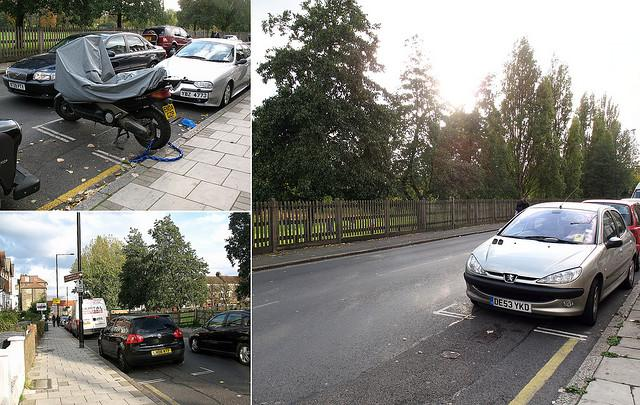What does the grey cloth do? Please explain your reasoning. keep dry. The cloth covers the bike. 